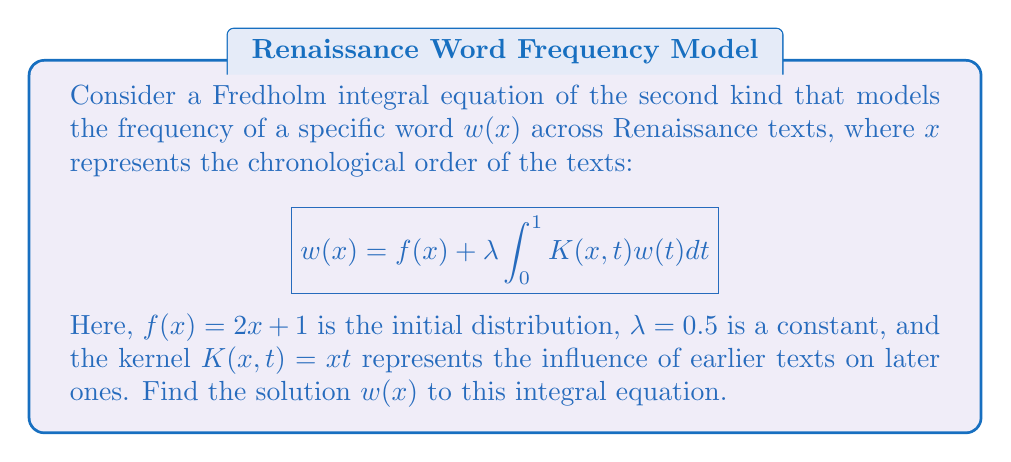Provide a solution to this math problem. To solve this Fredholm integral equation, we'll follow these steps:

1) First, we assume that the solution has the form $w(x) = ax + b$ where $a$ and $b$ are constants to be determined.

2) Substitute this into the integral equation:

   $$(ax + b) = (2x + 1) + 0.5 \int_0^1 xt(at + b)dt$$

3) Evaluate the integral:

   $$\int_0^1 xt(at + b)dt = x\int_0^1 (at^2 + bt)dt = x(\frac{a}{3} + \frac{b}{2})$$

4) Substituting back:

   $$(ax + b) = (2x + 1) + 0.5x(\frac{a}{3} + \frac{b}{2})$$

5) Simplify:

   $$ax + b = 2x + 1 + \frac{ax}{6} + \frac{bx}{4}$$

6) Equate coefficients of $x$ and constant terms:

   For $x$: $a = 2 + \frac{a}{6} + \frac{b}{4}$
   For constant: $b = 1$

7) From the second equation, we know $b = 1$. Substitute this into the first equation:

   $$a = 2 + \frac{a}{6} + \frac{1}{4}$$

8) Solve for $a$:

   $$\frac{5a}{6} = \frac{9}{4}$$
   $$a = \frac{27}{10} = 2.7$$

9) Therefore, the solution is:

   $$w(x) = 2.7x + 1$$
Answer: $w(x) = 2.7x + 1$ 